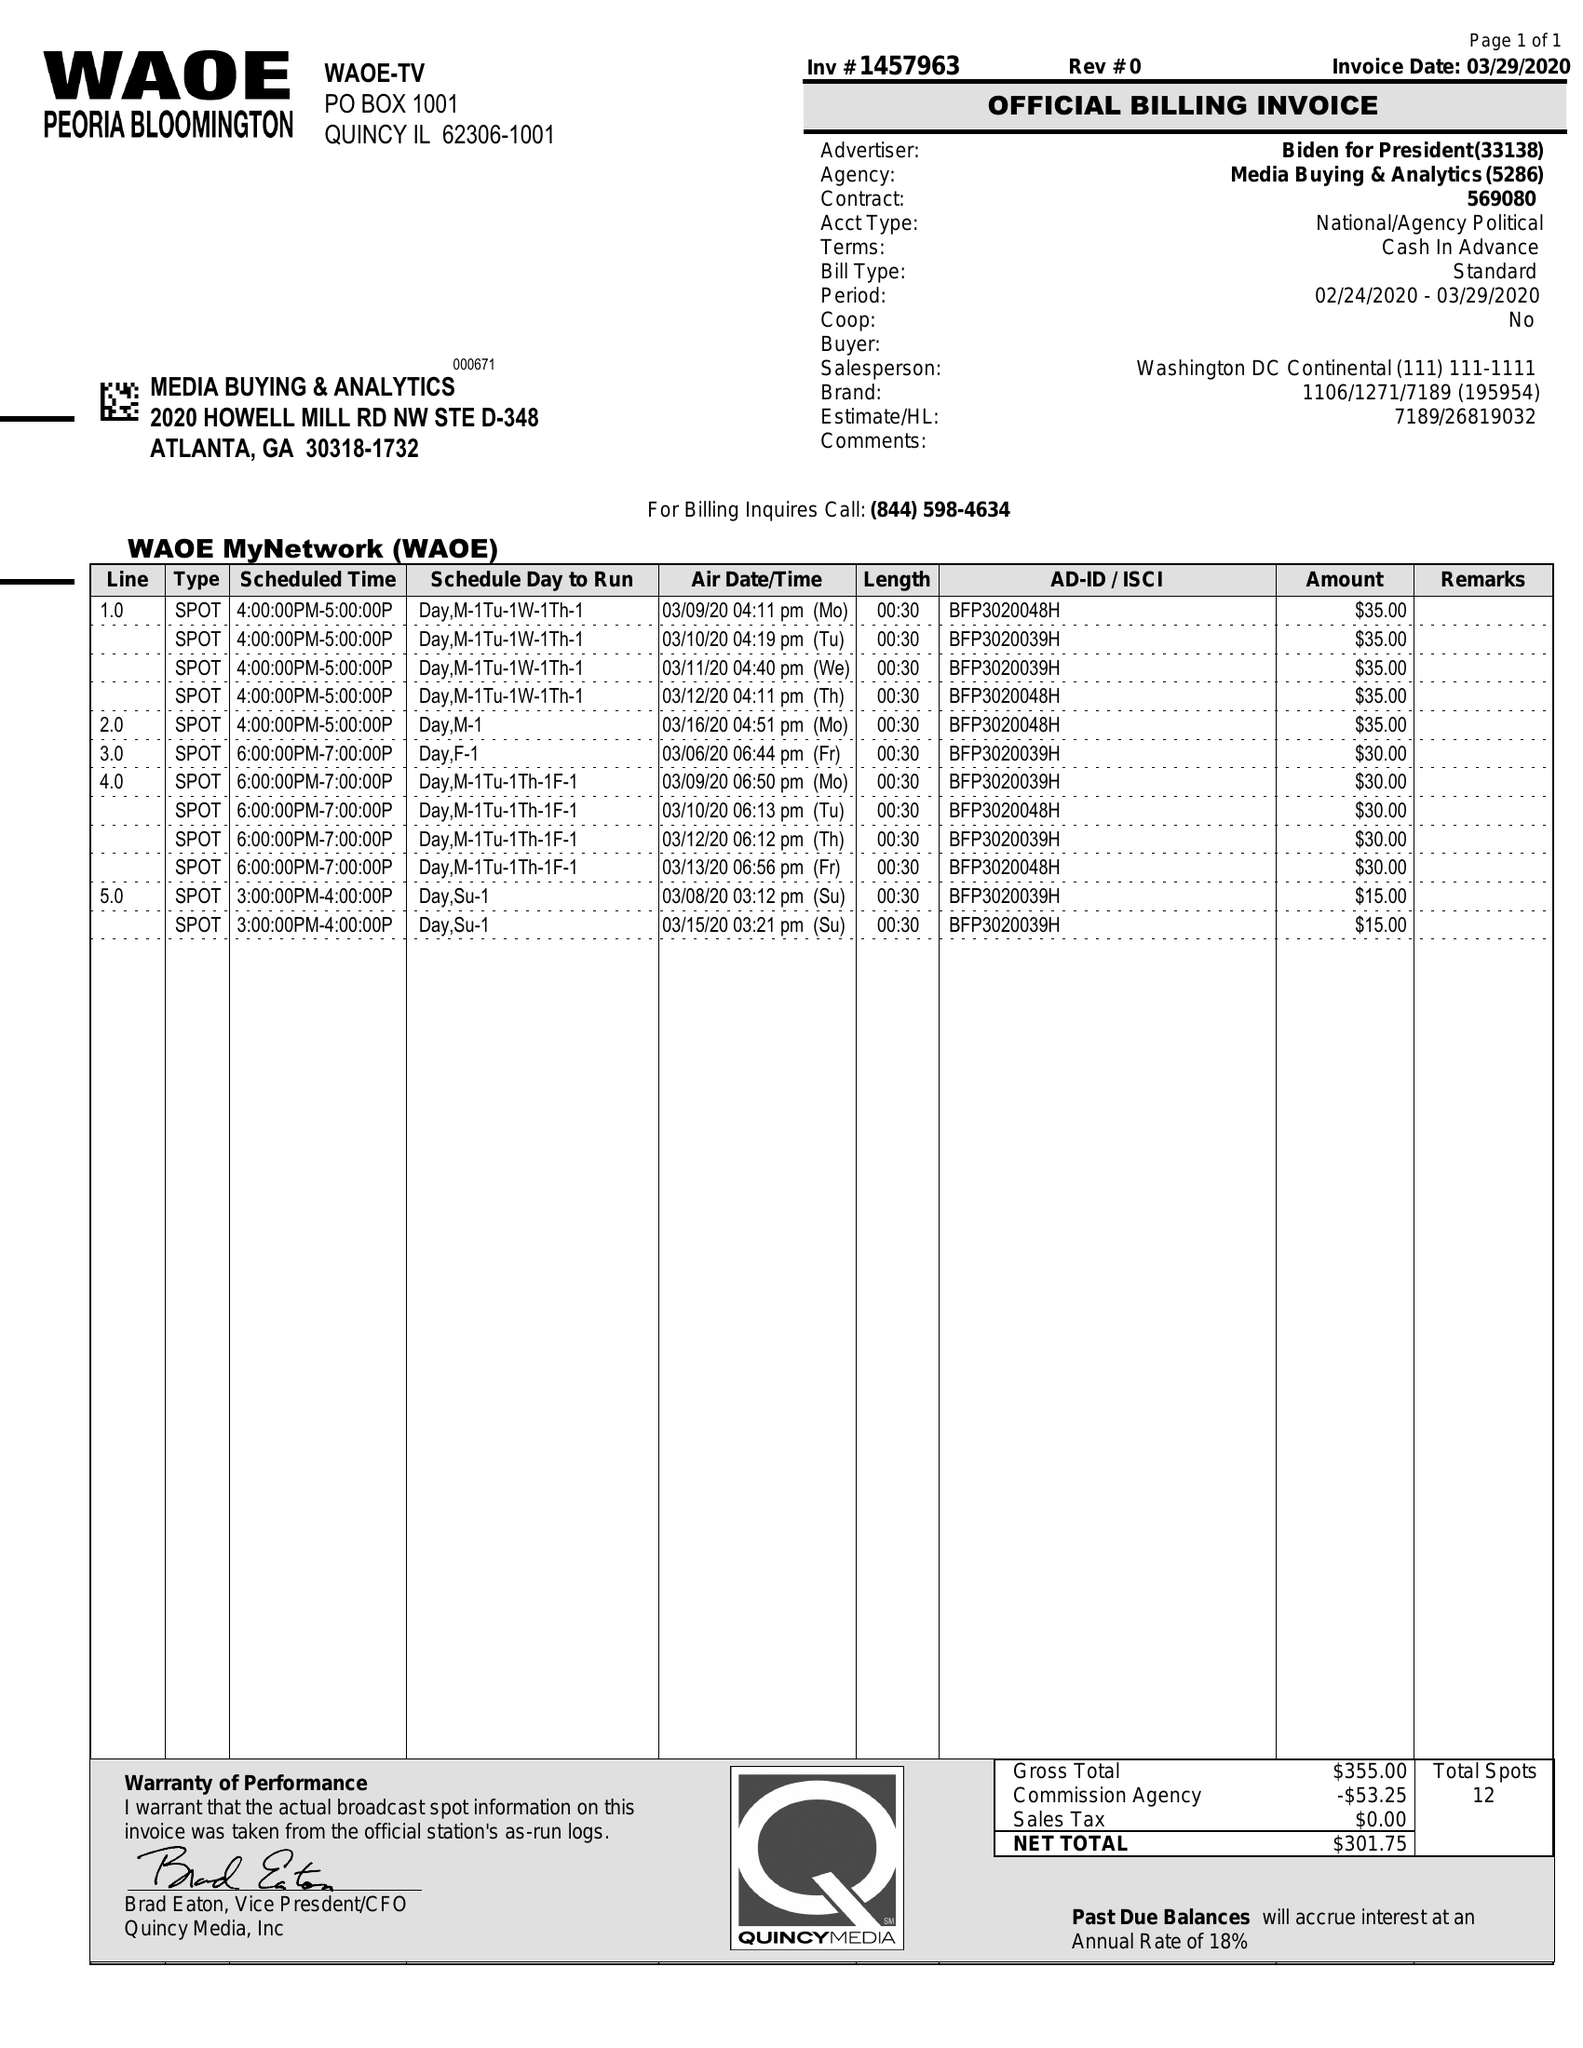What is the value for the gross_amount?
Answer the question using a single word or phrase. 355.00 